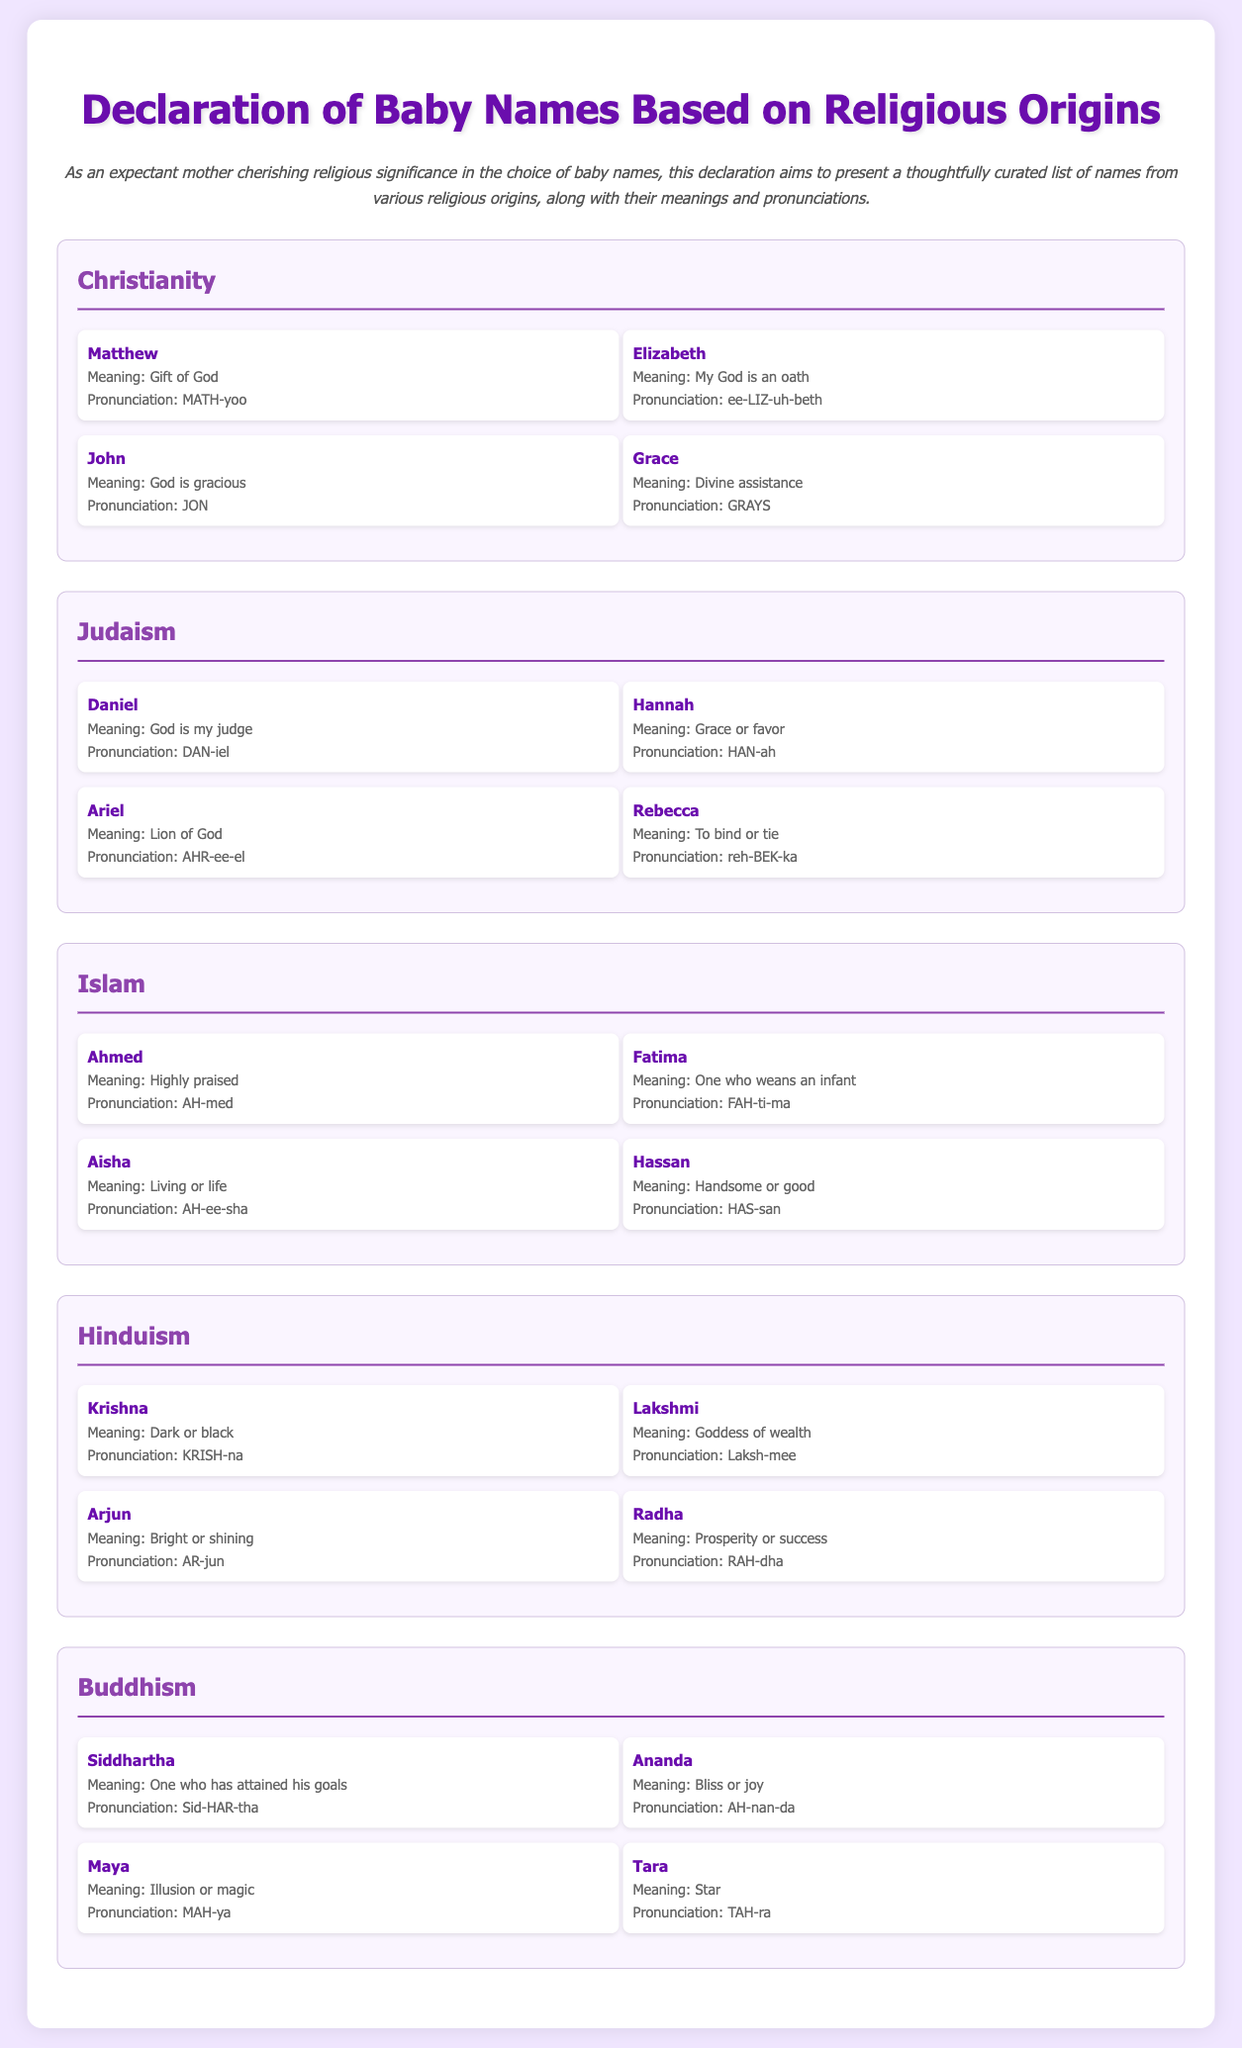What is the meaning of the name Matthew? The meaning of Matthew is specifically stated in the Christianity section as "Gift of God."
Answer: Gift of God How many names are listed under Islam? The total number of names in the Islam category can be counted and is stated as four names.
Answer: 4 What is the pronunciation of the name Hannah? The pronunciation of Hannah is explicitly provided in the Judaism section as "HAN-ah."
Answer: HAN-ah Which name means "God is gracious"? The name John in the Christianity section is specified to mean "God is gracious."
Answer: John Which religious origin does the name Lakshmi belong to? The name Lakshmi is clearly categorized under Hinduism in the document.
Answer: Hinduism What is the meaning of the name Fatima? The meaning of Fatima is detailed in the Islam section as "One who weans an infant."
Answer: One who weans an infant How many names are listed in total across all religions? The total count of names can be calculated from the sections provided and is 20 names.
Answer: 20 Which name means "Star"? The name Tara is indicated in the Buddhism section to mean "Star."
Answer: Tara What color is the background of the document? The background color of the document is described as #f0e6ff.
Answer: #f0e6ff 